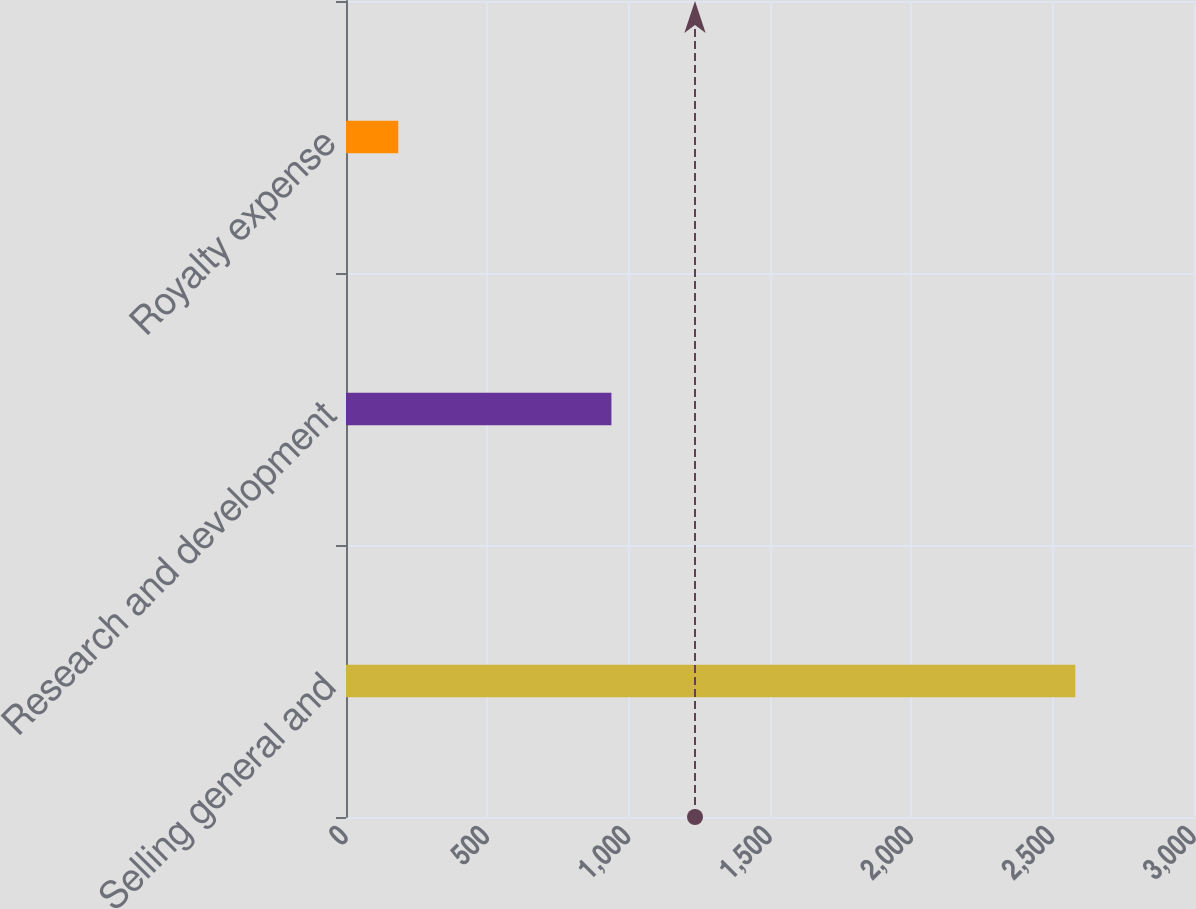Convert chart. <chart><loc_0><loc_0><loc_500><loc_500><bar_chart><fcel>Selling general and<fcel>Research and development<fcel>Royalty expense<nl><fcel>2580<fcel>939<fcel>185<nl></chart> 